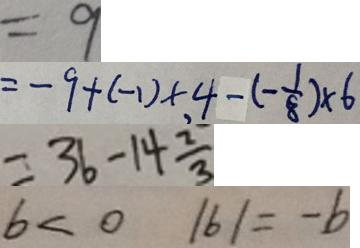Convert formula to latex. <formula><loc_0><loc_0><loc_500><loc_500>= 9 
 = - 9 + ( - 1 ) \times , 4 - ( - \frac { 1 } { 8 } ) \times 6 
 = 3 6 - 1 4 \frac { 2 } { 3 } 
 b < 0 \vert b \vert = - b</formula> 